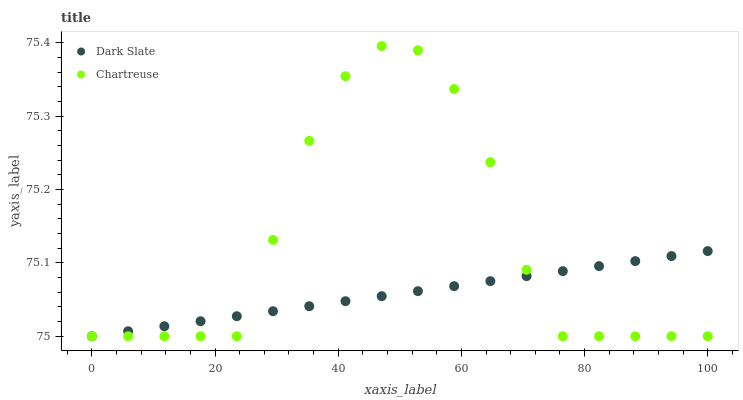Does Dark Slate have the minimum area under the curve?
Answer yes or no. Yes. Does Chartreuse have the maximum area under the curve?
Answer yes or no. Yes. Does Chartreuse have the minimum area under the curve?
Answer yes or no. No. Is Dark Slate the smoothest?
Answer yes or no. Yes. Is Chartreuse the roughest?
Answer yes or no. Yes. Is Chartreuse the smoothest?
Answer yes or no. No. Does Dark Slate have the lowest value?
Answer yes or no. Yes. Does Chartreuse have the highest value?
Answer yes or no. Yes. Does Dark Slate intersect Chartreuse?
Answer yes or no. Yes. Is Dark Slate less than Chartreuse?
Answer yes or no. No. Is Dark Slate greater than Chartreuse?
Answer yes or no. No. 